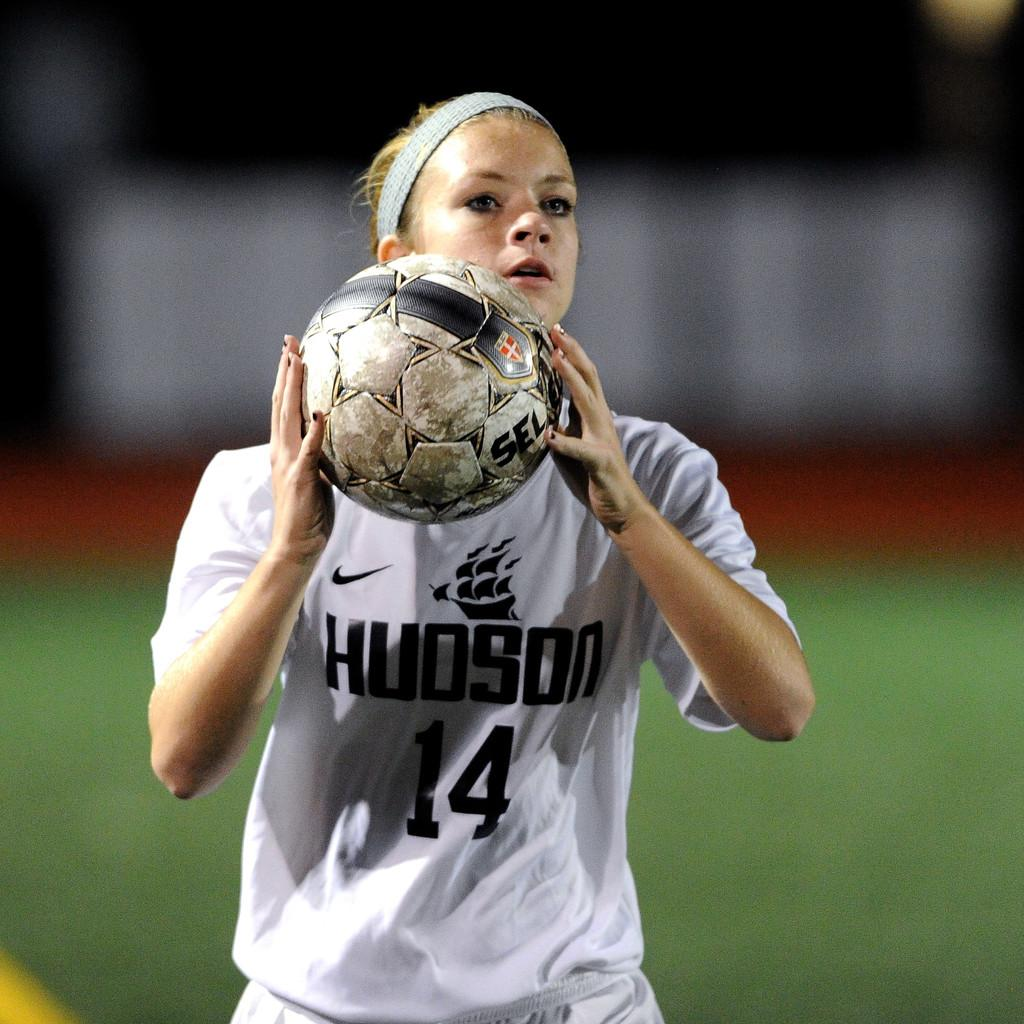<image>
Create a compact narrative representing the image presented. a sports woman in a Hudson 14 jersey holds a soccer ball 